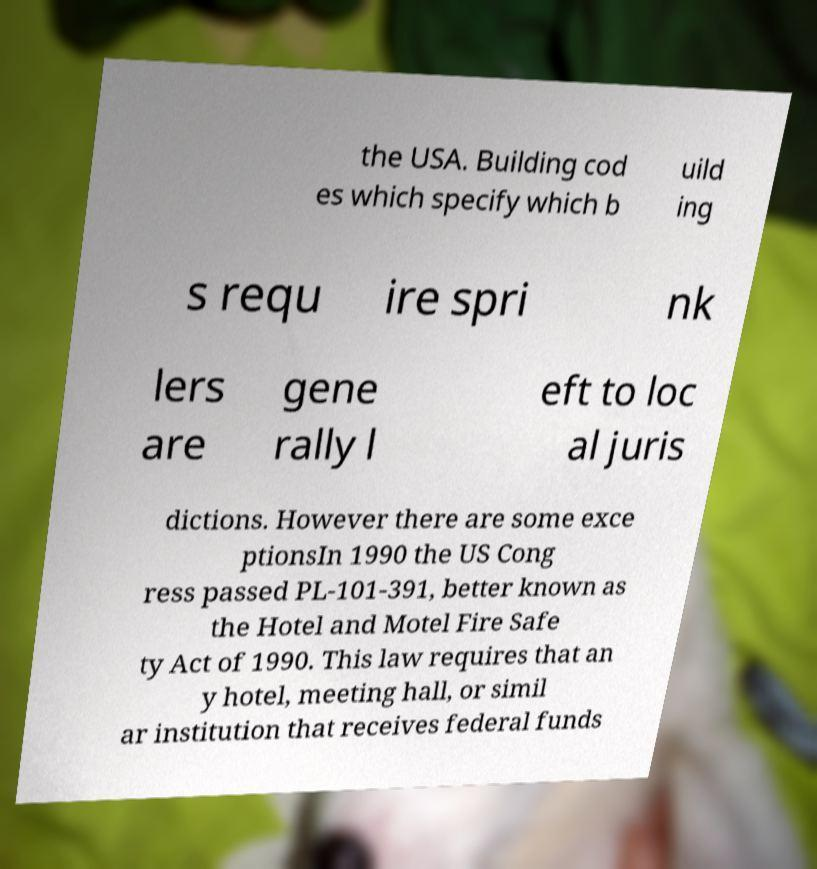Can you accurately transcribe the text from the provided image for me? the USA. Building cod es which specify which b uild ing s requ ire spri nk lers are gene rally l eft to loc al juris dictions. However there are some exce ptionsIn 1990 the US Cong ress passed PL-101-391, better known as the Hotel and Motel Fire Safe ty Act of 1990. This law requires that an y hotel, meeting hall, or simil ar institution that receives federal funds 